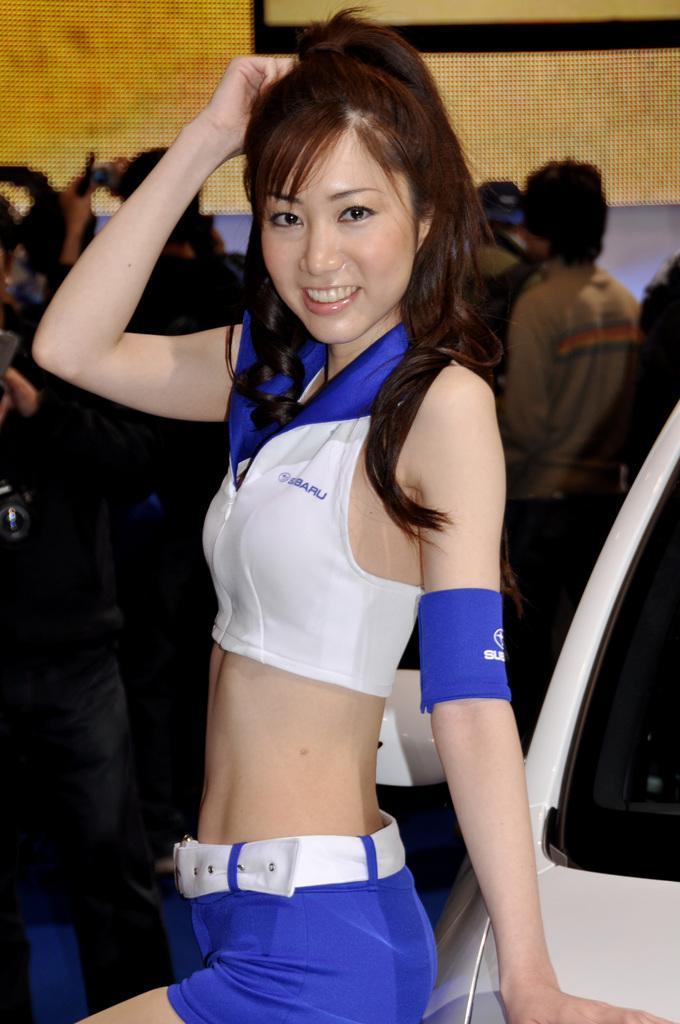Please provide a concise description of this image. In this image there is a woman who is wearing the white top and blue short is standing beside the car by keeping her hand on it. In the background there are so many people. At the top there is a wall in the background. 